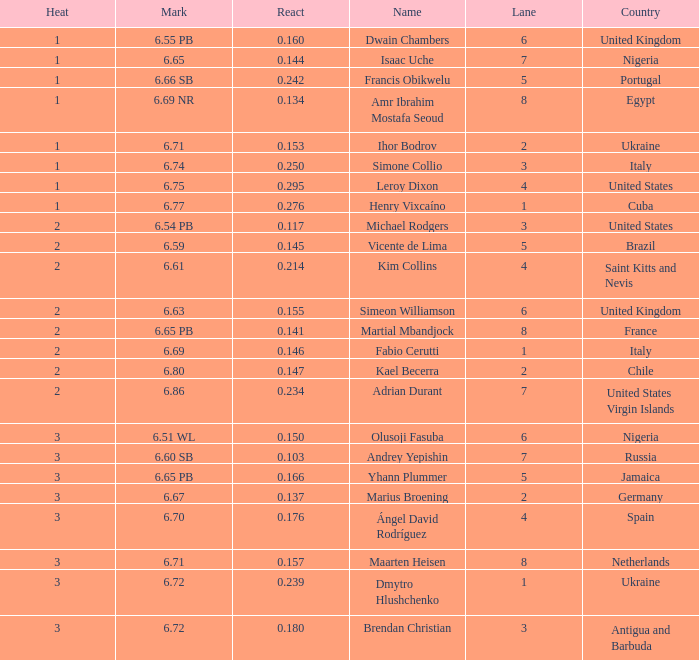What is the lowest Lane, when Country is France, and when React is less than 0.14100000000000001? 8.0. 